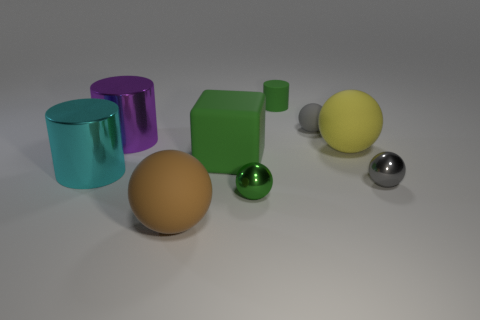Subtract all brown matte spheres. How many spheres are left? 4 Subtract all yellow balls. How many balls are left? 4 Subtract 1 spheres. How many spheres are left? 4 Subtract all red spheres. Subtract all cyan cylinders. How many spheres are left? 5 Add 1 rubber things. How many objects exist? 10 Subtract all balls. How many objects are left? 4 Subtract 0 brown cubes. How many objects are left? 9 Subtract all tiny spheres. Subtract all matte cylinders. How many objects are left? 5 Add 3 small green spheres. How many small green spheres are left? 4 Add 7 gray shiny cylinders. How many gray shiny cylinders exist? 7 